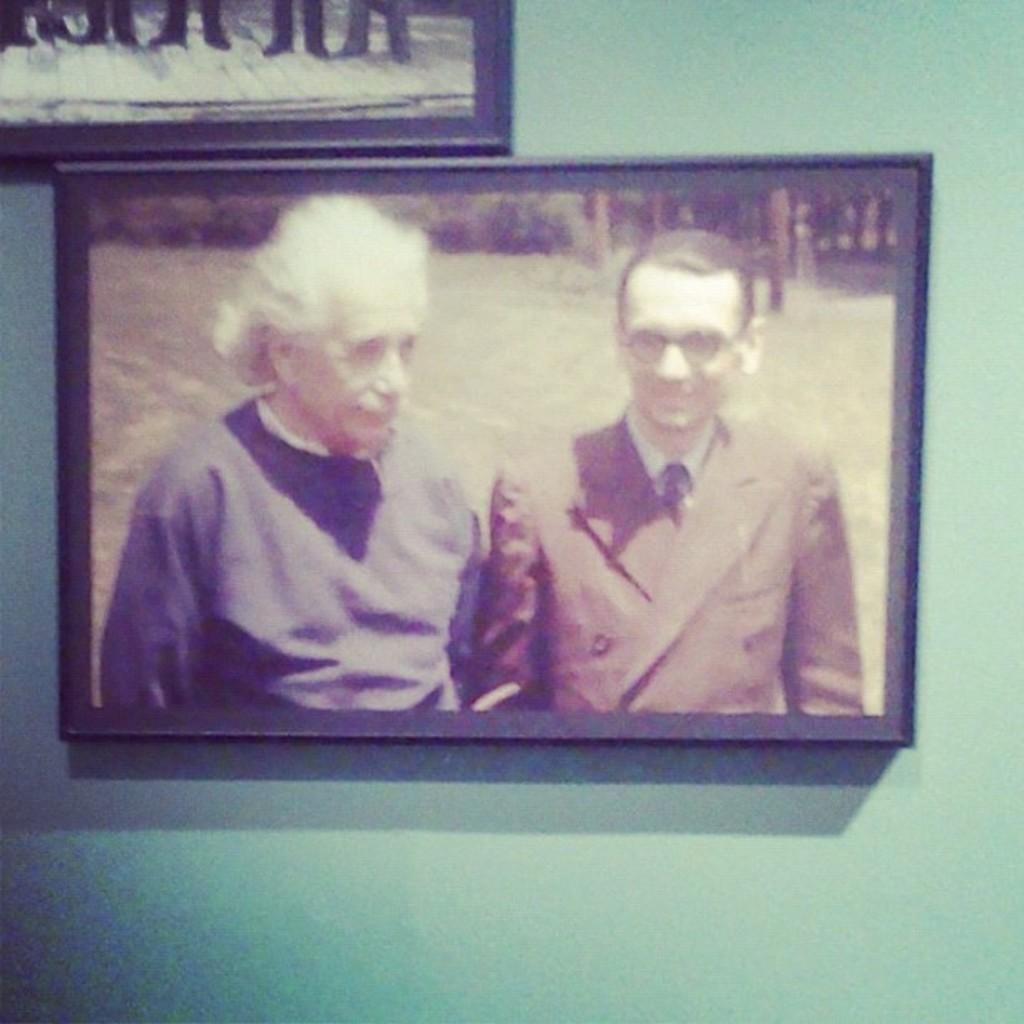What is hanging on the wall in the image? There is a picture on the wall in the image. What is depicted in the picture? The picture contains an image of Einstein. Can you describe the man standing in the image? There is a man standing at the right side of the image. What type of disgust can be seen on the faces of the people in the park in the image? There is no park or people present in the image; it only features a picture of Einstein on the wall and a man standing nearby. 